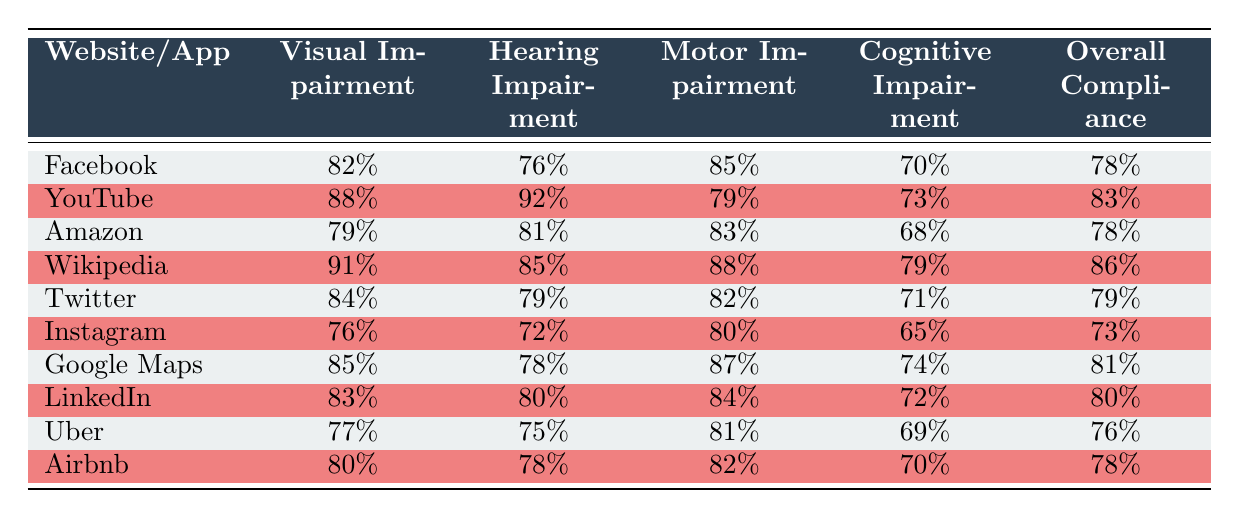What is the accessibility compliance rate for Facebook? The table clearly shows that Facebook has an overall compliance rate of 78%.
Answer: 78% Which website/app has the highest compliance rate for visual impairment? By inspecting the "Visual Impairment" column, Wikipedia has the highest compliance at 91%.
Answer: 91% What is the overall compliance rate for YouTube? The table indicates YouTube's overall compliance rate is 83%.
Answer: 83% Does Instagram have a higher compliance rate for cognitive impairment compared to Uber? Instagram has a cognitive impairment compliance rate of 65%, whereas Uber has 69%. Since 65% is less than 69%, the answer is no.
Answer: No What is the average overall compliance rate for all the websites/apps listed? To calculate the average, add all overall compliance rates: (78 + 83 + 78 + 86 + 79 + 73 + 81 + 80 + 76 + 78) =  79.2. Given there are 10 data points, the average is 792/10 = 79.2.
Answer: 79.2 Which app has better compliance for motor impairment, Google Maps or LinkedIn? Google Maps has a compliance rate of 87% for motor impairment, while LinkedIn has 84%. Since 87% is greater than 84%, Google Maps is better in this category.
Answer: Google Maps Is the compliance rate for hearing impairment for Wikipedia higher than that for Amazon? Wikipedia's hearing impairment compliance rate is 85%, while Amazon's is 81%. Since 85% is greater than 81%, the answer is yes.
Answer: Yes What is the difference in compliance rates for visual impairment between YouTube and Twitter? YouTube has a visual impairment compliance rate of 88% while Twitter has 84%. The difference is 88% - 84% = 4%.
Answer: 4% 